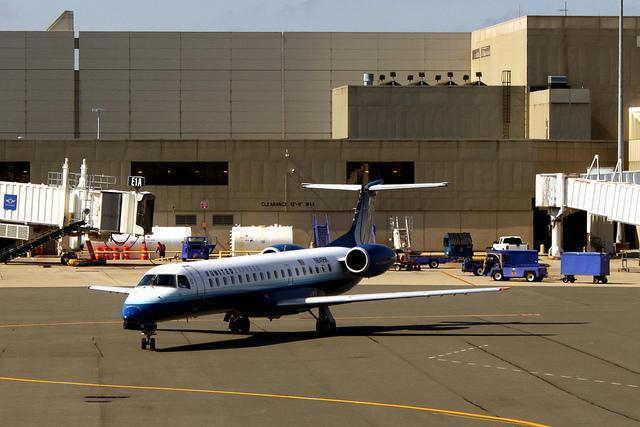How many cars are on the right of the horses and riders?
Give a very brief answer. 0. 